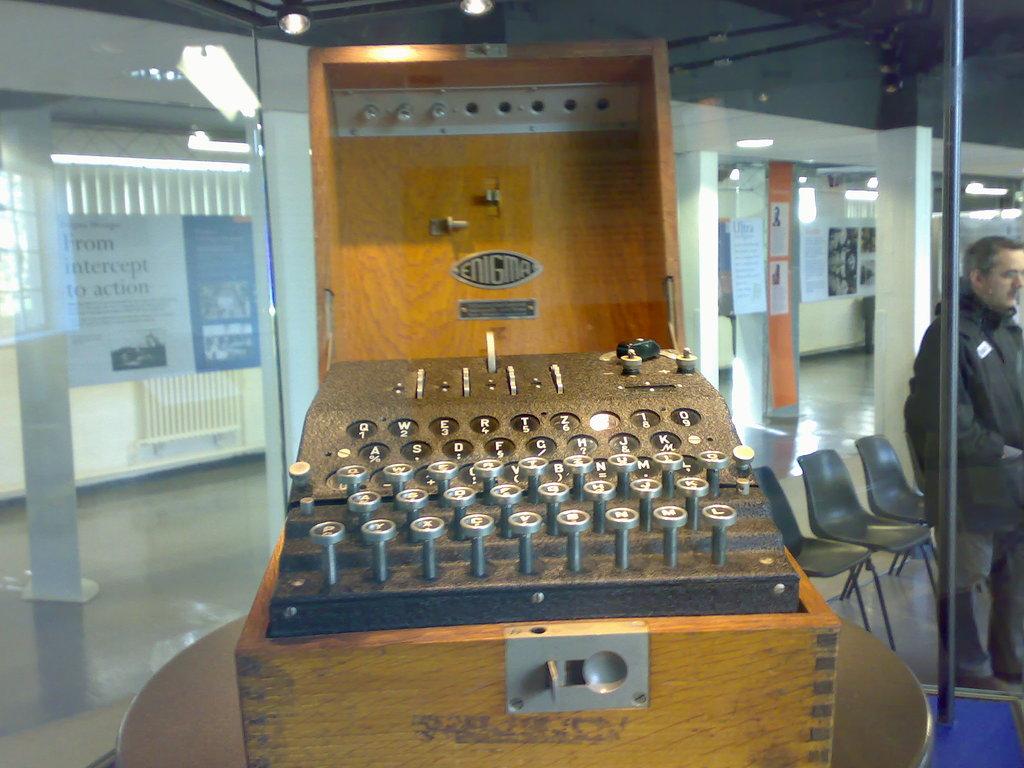What is the brand of typewriter?
Give a very brief answer. Enigma. 